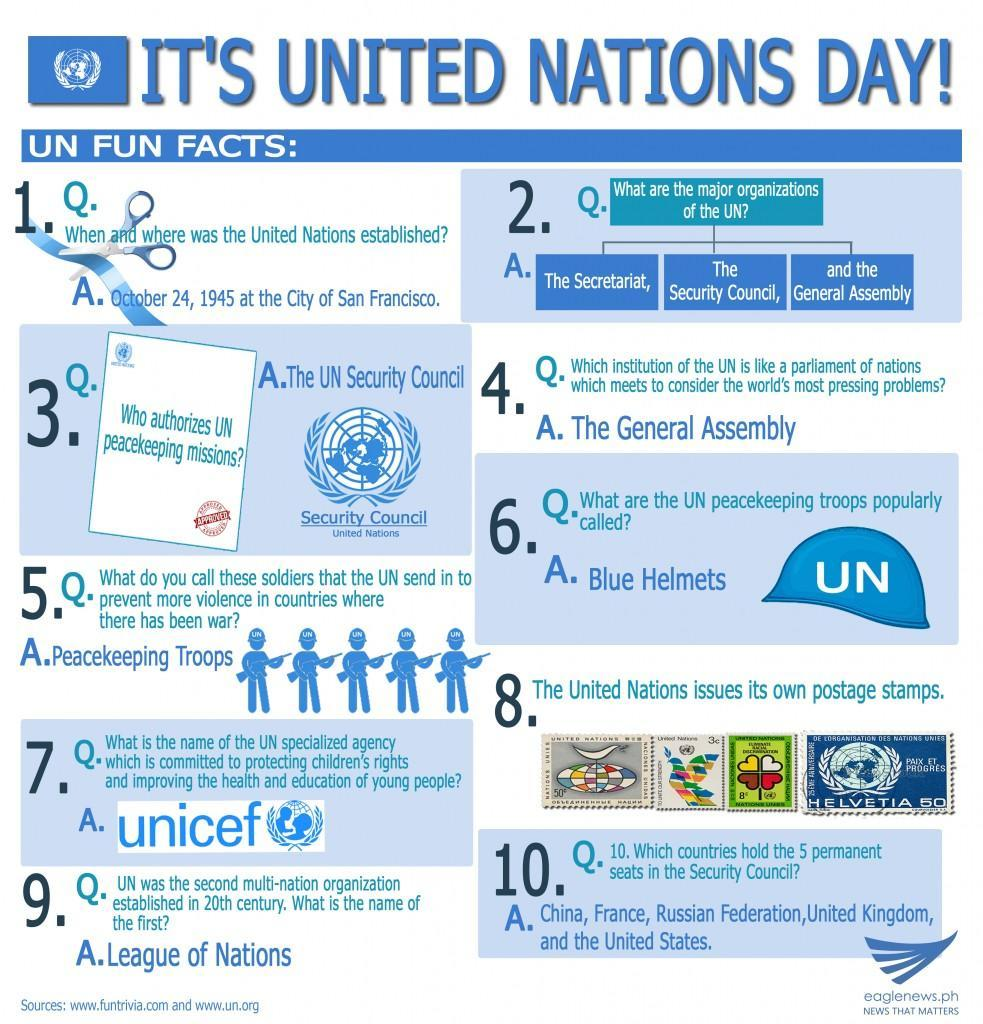Which organization controls peace keeping?
Answer the question with a short phrase. The UN Security Council How many major organizations does UN have? 3 